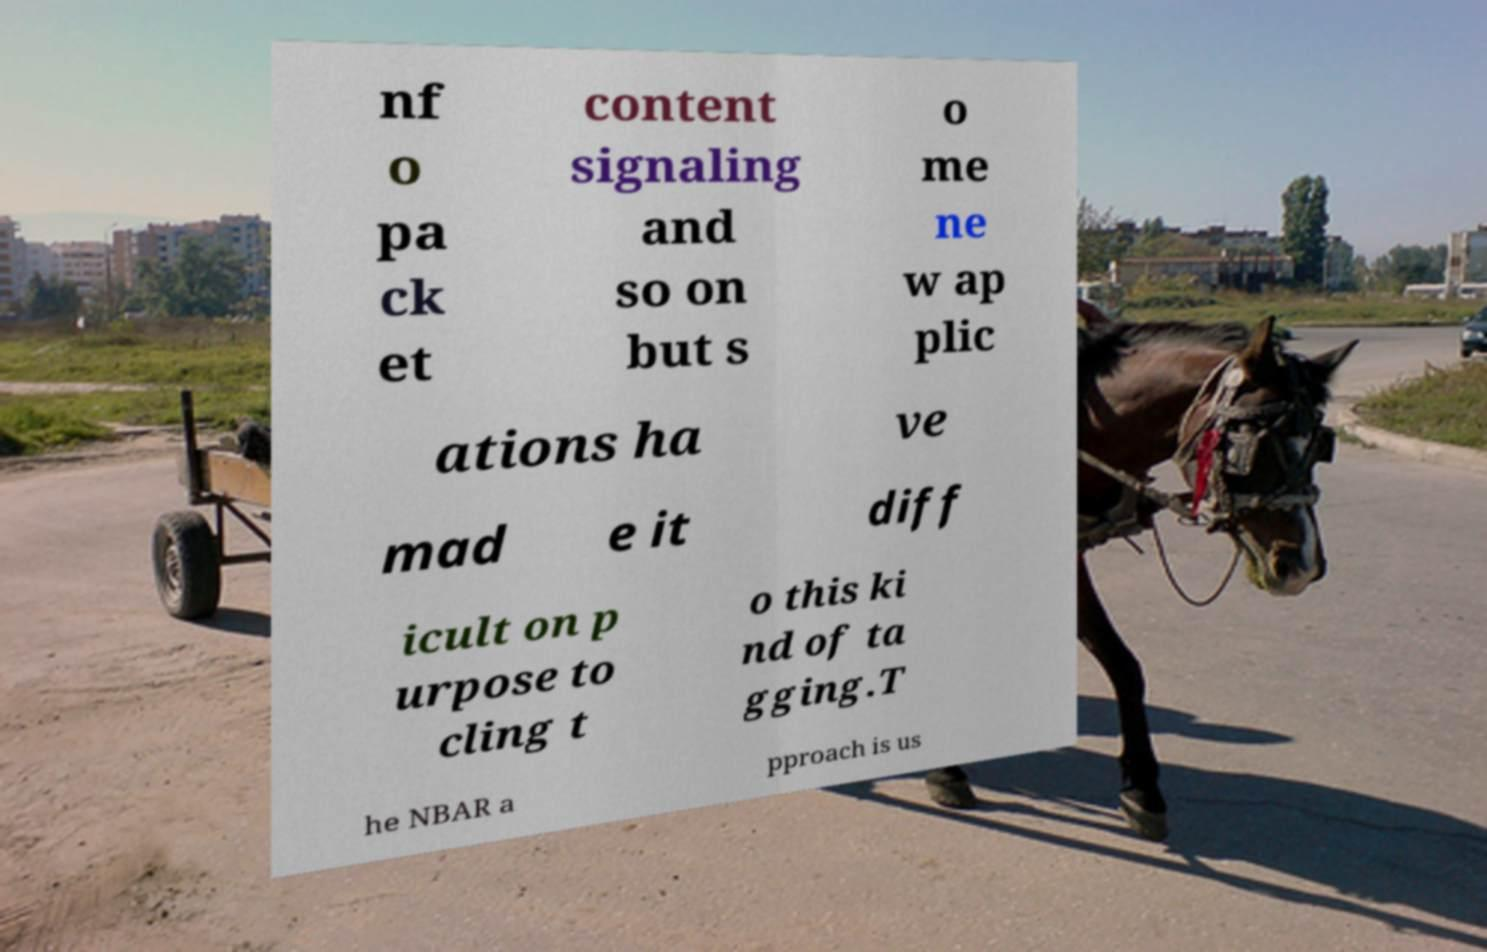Please identify and transcribe the text found in this image. nf o pa ck et content signaling and so on but s o me ne w ap plic ations ha ve mad e it diff icult on p urpose to cling t o this ki nd of ta gging.T he NBAR a pproach is us 